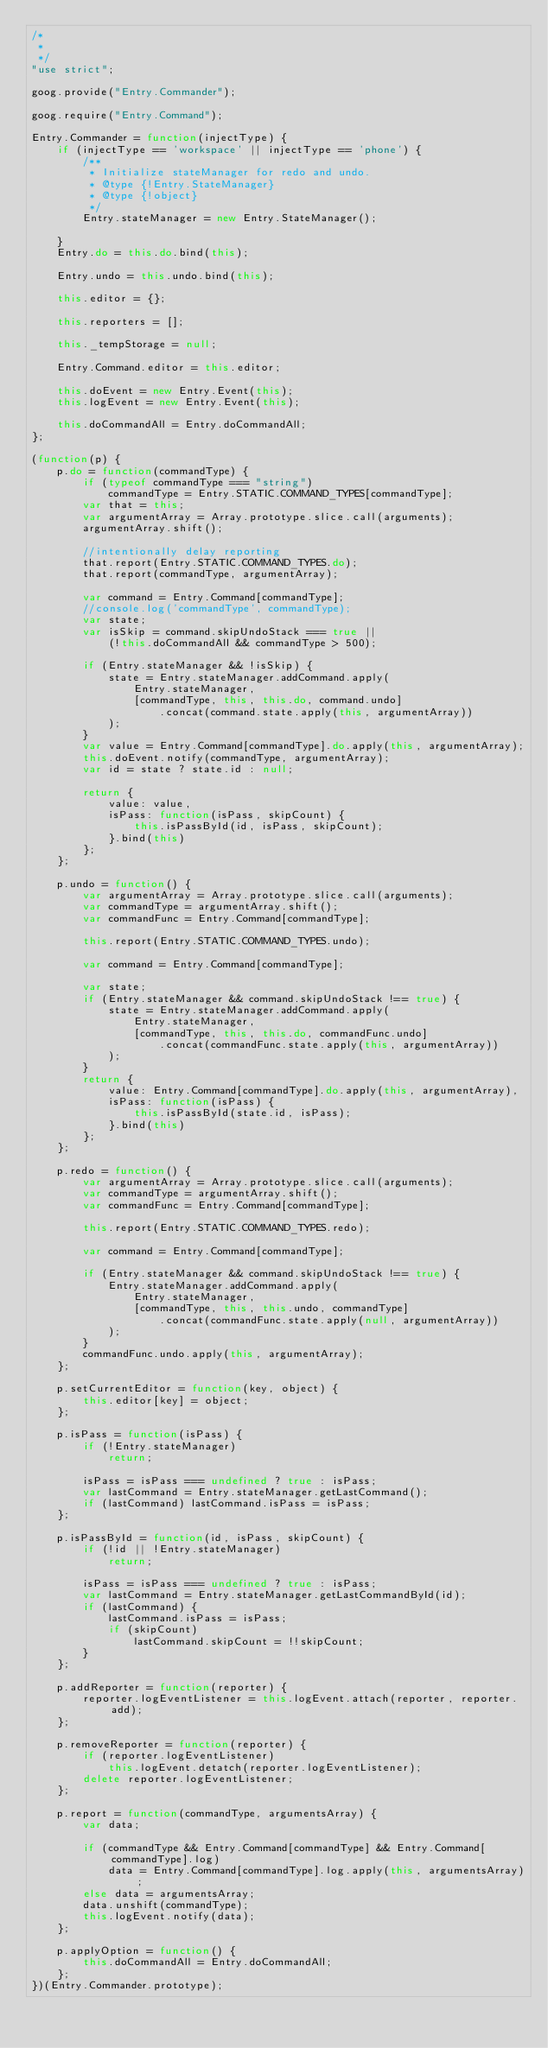<code> <loc_0><loc_0><loc_500><loc_500><_JavaScript_>/*
 *
 */
"use strict";

goog.provide("Entry.Commander");

goog.require("Entry.Command");

Entry.Commander = function(injectType) {
    if (injectType == 'workspace' || injectType == 'phone') {
        /**
         * Initialize stateManager for redo and undo.
         * @type {!Entry.StateManager}
         * @type {!object}
         */
        Entry.stateManager = new Entry.StateManager();

    }
    Entry.do = this.do.bind(this);

    Entry.undo = this.undo.bind(this);

    this.editor = {};

    this.reporters = [];

    this._tempStorage = null;

    Entry.Command.editor = this.editor;

    this.doEvent = new Entry.Event(this);
    this.logEvent = new Entry.Event(this);

    this.doCommandAll = Entry.doCommandAll;
};

(function(p) {
    p.do = function(commandType) {
        if (typeof commandType === "string")
            commandType = Entry.STATIC.COMMAND_TYPES[commandType];
        var that = this;
        var argumentArray = Array.prototype.slice.call(arguments);
        argumentArray.shift();

        //intentionally delay reporting
        that.report(Entry.STATIC.COMMAND_TYPES.do);
        that.report(commandType, argumentArray);

        var command = Entry.Command[commandType];
        //console.log('commandType', commandType);
        var state;
        var isSkip = command.skipUndoStack === true ||
            (!this.doCommandAll && commandType > 500);

        if (Entry.stateManager && !isSkip) {
            state = Entry.stateManager.addCommand.apply(
                Entry.stateManager,
                [commandType, this, this.do, command.undo]
                    .concat(command.state.apply(this, argumentArray))
            );
        }
        var value = Entry.Command[commandType].do.apply(this, argumentArray);
        this.doEvent.notify(commandType, argumentArray);
        var id = state ? state.id : null;

        return {
            value: value,
            isPass: function(isPass, skipCount) {
                this.isPassById(id, isPass, skipCount);
            }.bind(this)
        };
    };

    p.undo = function() {
        var argumentArray = Array.prototype.slice.call(arguments);
        var commandType = argumentArray.shift();
        var commandFunc = Entry.Command[commandType];

        this.report(Entry.STATIC.COMMAND_TYPES.undo);

        var command = Entry.Command[commandType];

        var state;
        if (Entry.stateManager && command.skipUndoStack !== true) {
            state = Entry.stateManager.addCommand.apply(
                Entry.stateManager,
                [commandType, this, this.do, commandFunc.undo]
                    .concat(commandFunc.state.apply(this, argumentArray))
            );
        }
        return {
            value: Entry.Command[commandType].do.apply(this, argumentArray),
            isPass: function(isPass) {
                this.isPassById(state.id, isPass);
            }.bind(this)
        };
    };

    p.redo = function() {
        var argumentArray = Array.prototype.slice.call(arguments);
        var commandType = argumentArray.shift();
        var commandFunc = Entry.Command[commandType];

        this.report(Entry.STATIC.COMMAND_TYPES.redo);

        var command = Entry.Command[commandType];

        if (Entry.stateManager && command.skipUndoStack !== true) {
            Entry.stateManager.addCommand.apply(
                Entry.stateManager,
                [commandType, this, this.undo, commandType]
                    .concat(commandFunc.state.apply(null, argumentArray))
            );
        }
        commandFunc.undo.apply(this, argumentArray);
    };

    p.setCurrentEditor = function(key, object) {
        this.editor[key] = object;
    };

    p.isPass = function(isPass) {
        if (!Entry.stateManager)
            return;

        isPass = isPass === undefined ? true : isPass;
        var lastCommand = Entry.stateManager.getLastCommand();
        if (lastCommand) lastCommand.isPass = isPass;
    };

    p.isPassById = function(id, isPass, skipCount) {
        if (!id || !Entry.stateManager)
            return;

        isPass = isPass === undefined ? true : isPass;
        var lastCommand = Entry.stateManager.getLastCommandById(id);
        if (lastCommand) {
            lastCommand.isPass = isPass;
            if (skipCount)
                lastCommand.skipCount = !!skipCount;
        }
    };

    p.addReporter = function(reporter) {
        reporter.logEventListener = this.logEvent.attach(reporter, reporter.add);
    };

    p.removeReporter = function(reporter) {
        if (reporter.logEventListener)
            this.logEvent.detatch(reporter.logEventListener);
        delete reporter.logEventListener;
    };

    p.report = function(commandType, argumentsArray) {
        var data;

        if (commandType && Entry.Command[commandType] && Entry.Command[commandType].log)
            data = Entry.Command[commandType].log.apply(this, argumentsArray);
        else data = argumentsArray;
        data.unshift(commandType);
        this.logEvent.notify(data);
    };

    p.applyOption = function() {
        this.doCommandAll = Entry.doCommandAll;
    };
})(Entry.Commander.prototype);

</code> 